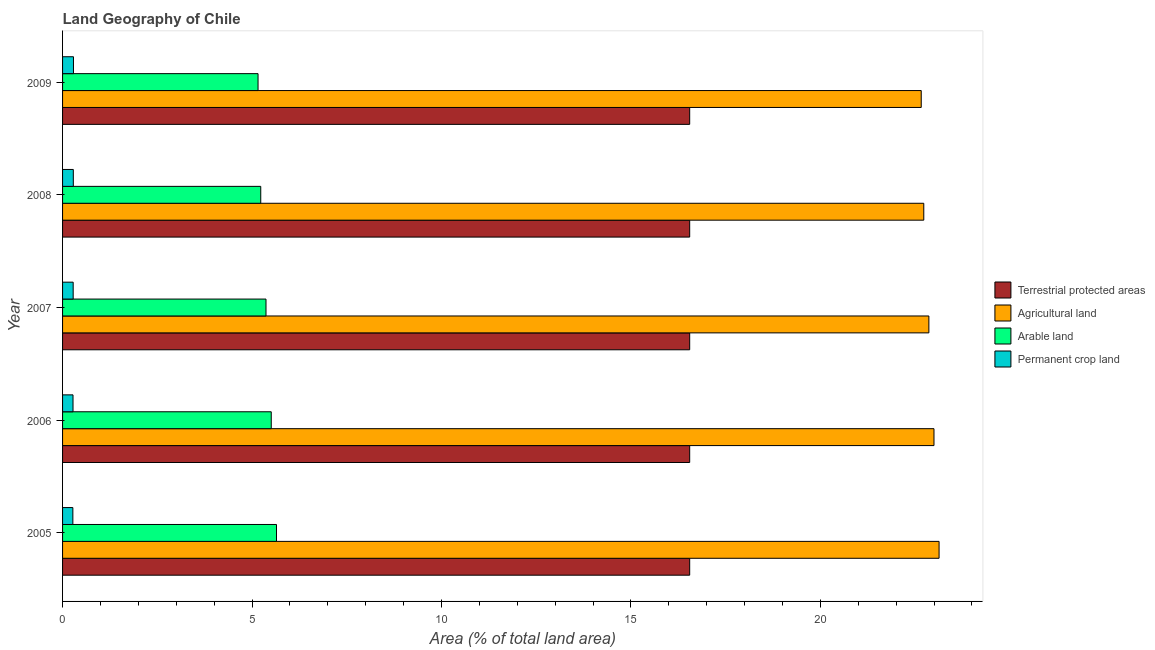Are the number of bars on each tick of the Y-axis equal?
Keep it short and to the point. Yes. How many bars are there on the 3rd tick from the bottom?
Give a very brief answer. 4. What is the label of the 5th group of bars from the top?
Ensure brevity in your answer.  2005. What is the percentage of area under arable land in 2005?
Your answer should be compact. 5.65. Across all years, what is the maximum percentage of area under agricultural land?
Your answer should be very brief. 23.13. Across all years, what is the minimum percentage of land under terrestrial protection?
Make the answer very short. 16.55. In which year was the percentage of area under permanent crop land maximum?
Give a very brief answer. 2009. In which year was the percentage of area under permanent crop land minimum?
Provide a succinct answer. 2005. What is the total percentage of area under arable land in the graph?
Provide a succinct answer. 26.91. What is the difference between the percentage of area under agricultural land in 2005 and that in 2007?
Provide a succinct answer. 0.27. What is the difference between the percentage of land under terrestrial protection in 2006 and the percentage of area under agricultural land in 2007?
Provide a succinct answer. -6.31. What is the average percentage of area under arable land per year?
Provide a succinct answer. 5.38. In the year 2005, what is the difference between the percentage of land under terrestrial protection and percentage of area under permanent crop land?
Ensure brevity in your answer.  16.28. In how many years, is the percentage of land under terrestrial protection greater than 1 %?
Your response must be concise. 5. What is the ratio of the percentage of area under permanent crop land in 2006 to that in 2009?
Ensure brevity in your answer.  0.96. What is the difference between the highest and the second highest percentage of area under permanent crop land?
Ensure brevity in your answer.  0. What is the difference between the highest and the lowest percentage of land under terrestrial protection?
Ensure brevity in your answer.  0. In how many years, is the percentage of land under terrestrial protection greater than the average percentage of land under terrestrial protection taken over all years?
Give a very brief answer. 0. Is the sum of the percentage of land under terrestrial protection in 2008 and 2009 greater than the maximum percentage of area under permanent crop land across all years?
Your answer should be compact. Yes. Is it the case that in every year, the sum of the percentage of area under agricultural land and percentage of area under permanent crop land is greater than the sum of percentage of land under terrestrial protection and percentage of area under arable land?
Give a very brief answer. Yes. What does the 2nd bar from the top in 2007 represents?
Ensure brevity in your answer.  Arable land. What does the 3rd bar from the bottom in 2006 represents?
Make the answer very short. Arable land. Is it the case that in every year, the sum of the percentage of land under terrestrial protection and percentage of area under agricultural land is greater than the percentage of area under arable land?
Offer a terse response. Yes. How many bars are there?
Your response must be concise. 20. How many years are there in the graph?
Provide a succinct answer. 5. Does the graph contain any zero values?
Ensure brevity in your answer.  No. How are the legend labels stacked?
Make the answer very short. Vertical. What is the title of the graph?
Give a very brief answer. Land Geography of Chile. Does "Rule based governance" appear as one of the legend labels in the graph?
Provide a short and direct response. No. What is the label or title of the X-axis?
Offer a very short reply. Area (% of total land area). What is the Area (% of total land area) of Terrestrial protected areas in 2005?
Keep it short and to the point. 16.55. What is the Area (% of total land area) of Agricultural land in 2005?
Make the answer very short. 23.13. What is the Area (% of total land area) in Arable land in 2005?
Ensure brevity in your answer.  5.65. What is the Area (% of total land area) in Permanent crop land in 2005?
Provide a succinct answer. 0.27. What is the Area (% of total land area) in Terrestrial protected areas in 2006?
Offer a very short reply. 16.55. What is the Area (% of total land area) in Agricultural land in 2006?
Ensure brevity in your answer.  23. What is the Area (% of total land area) of Arable land in 2006?
Your answer should be compact. 5.51. What is the Area (% of total land area) of Permanent crop land in 2006?
Keep it short and to the point. 0.28. What is the Area (% of total land area) in Terrestrial protected areas in 2007?
Ensure brevity in your answer.  16.55. What is the Area (% of total land area) in Agricultural land in 2007?
Ensure brevity in your answer.  22.86. What is the Area (% of total land area) in Arable land in 2007?
Ensure brevity in your answer.  5.37. What is the Area (% of total land area) in Permanent crop land in 2007?
Ensure brevity in your answer.  0.28. What is the Area (% of total land area) of Terrestrial protected areas in 2008?
Your answer should be compact. 16.55. What is the Area (% of total land area) in Agricultural land in 2008?
Ensure brevity in your answer.  22.73. What is the Area (% of total land area) in Arable land in 2008?
Ensure brevity in your answer.  5.23. What is the Area (% of total land area) in Permanent crop land in 2008?
Ensure brevity in your answer.  0.28. What is the Area (% of total land area) of Terrestrial protected areas in 2009?
Provide a short and direct response. 16.55. What is the Area (% of total land area) of Agricultural land in 2009?
Your response must be concise. 22.66. What is the Area (% of total land area) in Arable land in 2009?
Ensure brevity in your answer.  5.16. What is the Area (% of total land area) of Permanent crop land in 2009?
Make the answer very short. 0.29. Across all years, what is the maximum Area (% of total land area) of Terrestrial protected areas?
Give a very brief answer. 16.55. Across all years, what is the maximum Area (% of total land area) in Agricultural land?
Give a very brief answer. 23.13. Across all years, what is the maximum Area (% of total land area) in Arable land?
Give a very brief answer. 5.65. Across all years, what is the maximum Area (% of total land area) in Permanent crop land?
Give a very brief answer. 0.29. Across all years, what is the minimum Area (% of total land area) of Terrestrial protected areas?
Provide a succinct answer. 16.55. Across all years, what is the minimum Area (% of total land area) in Agricultural land?
Your answer should be very brief. 22.66. Across all years, what is the minimum Area (% of total land area) of Arable land?
Ensure brevity in your answer.  5.16. Across all years, what is the minimum Area (% of total land area) of Permanent crop land?
Give a very brief answer. 0.27. What is the total Area (% of total land area) in Terrestrial protected areas in the graph?
Offer a very short reply. 82.75. What is the total Area (% of total land area) of Agricultural land in the graph?
Provide a short and direct response. 114.39. What is the total Area (% of total land area) in Arable land in the graph?
Your answer should be compact. 26.91. What is the total Area (% of total land area) in Permanent crop land in the graph?
Your answer should be very brief. 1.4. What is the difference between the Area (% of total land area) of Agricultural land in 2005 and that in 2006?
Your answer should be compact. 0.13. What is the difference between the Area (% of total land area) in Arable land in 2005 and that in 2006?
Give a very brief answer. 0.14. What is the difference between the Area (% of total land area) in Permanent crop land in 2005 and that in 2006?
Your response must be concise. -0. What is the difference between the Area (% of total land area) of Terrestrial protected areas in 2005 and that in 2007?
Your answer should be very brief. 0. What is the difference between the Area (% of total land area) in Agricultural land in 2005 and that in 2007?
Your answer should be very brief. 0.27. What is the difference between the Area (% of total land area) of Arable land in 2005 and that in 2007?
Provide a succinct answer. 0.28. What is the difference between the Area (% of total land area) of Permanent crop land in 2005 and that in 2007?
Keep it short and to the point. -0.01. What is the difference between the Area (% of total land area) of Terrestrial protected areas in 2005 and that in 2008?
Your answer should be very brief. 0. What is the difference between the Area (% of total land area) in Agricultural land in 2005 and that in 2008?
Provide a succinct answer. 0.4. What is the difference between the Area (% of total land area) of Arable land in 2005 and that in 2008?
Your answer should be very brief. 0.42. What is the difference between the Area (% of total land area) in Permanent crop land in 2005 and that in 2008?
Provide a succinct answer. -0.01. What is the difference between the Area (% of total land area) of Agricultural land in 2005 and that in 2009?
Provide a succinct answer. 0.47. What is the difference between the Area (% of total land area) of Arable land in 2005 and that in 2009?
Your answer should be compact. 0.49. What is the difference between the Area (% of total land area) in Permanent crop land in 2005 and that in 2009?
Provide a short and direct response. -0.02. What is the difference between the Area (% of total land area) of Terrestrial protected areas in 2006 and that in 2007?
Give a very brief answer. 0. What is the difference between the Area (% of total land area) in Agricultural land in 2006 and that in 2007?
Keep it short and to the point. 0.13. What is the difference between the Area (% of total land area) of Arable land in 2006 and that in 2007?
Offer a very short reply. 0.14. What is the difference between the Area (% of total land area) of Permanent crop land in 2006 and that in 2007?
Your answer should be very brief. -0. What is the difference between the Area (% of total land area) in Terrestrial protected areas in 2006 and that in 2008?
Offer a very short reply. 0. What is the difference between the Area (% of total land area) of Agricultural land in 2006 and that in 2008?
Offer a terse response. 0.27. What is the difference between the Area (% of total land area) of Arable land in 2006 and that in 2008?
Offer a very short reply. 0.28. What is the difference between the Area (% of total land area) of Permanent crop land in 2006 and that in 2008?
Your response must be concise. -0.01. What is the difference between the Area (% of total land area) of Agricultural land in 2006 and that in 2009?
Your answer should be compact. 0.34. What is the difference between the Area (% of total land area) in Arable land in 2006 and that in 2009?
Offer a very short reply. 0.35. What is the difference between the Area (% of total land area) in Permanent crop land in 2006 and that in 2009?
Your response must be concise. -0.01. What is the difference between the Area (% of total land area) in Terrestrial protected areas in 2007 and that in 2008?
Your answer should be compact. 0. What is the difference between the Area (% of total land area) of Agricultural land in 2007 and that in 2008?
Provide a succinct answer. 0.13. What is the difference between the Area (% of total land area) in Arable land in 2007 and that in 2008?
Your answer should be compact. 0.14. What is the difference between the Area (% of total land area) of Permanent crop land in 2007 and that in 2008?
Your answer should be compact. -0. What is the difference between the Area (% of total land area) in Terrestrial protected areas in 2007 and that in 2009?
Make the answer very short. 0. What is the difference between the Area (% of total land area) of Agricultural land in 2007 and that in 2009?
Provide a succinct answer. 0.2. What is the difference between the Area (% of total land area) in Arable land in 2007 and that in 2009?
Provide a succinct answer. 0.21. What is the difference between the Area (% of total land area) of Permanent crop land in 2007 and that in 2009?
Make the answer very short. -0.01. What is the difference between the Area (% of total land area) in Terrestrial protected areas in 2008 and that in 2009?
Your answer should be very brief. 0. What is the difference between the Area (% of total land area) of Agricultural land in 2008 and that in 2009?
Your answer should be compact. 0.07. What is the difference between the Area (% of total land area) of Arable land in 2008 and that in 2009?
Provide a succinct answer. 0.07. What is the difference between the Area (% of total land area) of Permanent crop land in 2008 and that in 2009?
Your response must be concise. -0. What is the difference between the Area (% of total land area) of Terrestrial protected areas in 2005 and the Area (% of total land area) of Agricultural land in 2006?
Keep it short and to the point. -6.45. What is the difference between the Area (% of total land area) of Terrestrial protected areas in 2005 and the Area (% of total land area) of Arable land in 2006?
Provide a succinct answer. 11.04. What is the difference between the Area (% of total land area) in Terrestrial protected areas in 2005 and the Area (% of total land area) in Permanent crop land in 2006?
Your answer should be compact. 16.28. What is the difference between the Area (% of total land area) in Agricultural land in 2005 and the Area (% of total land area) in Arable land in 2006?
Give a very brief answer. 17.63. What is the difference between the Area (% of total land area) of Agricultural land in 2005 and the Area (% of total land area) of Permanent crop land in 2006?
Provide a succinct answer. 22.86. What is the difference between the Area (% of total land area) in Arable land in 2005 and the Area (% of total land area) in Permanent crop land in 2006?
Make the answer very short. 5.37. What is the difference between the Area (% of total land area) in Terrestrial protected areas in 2005 and the Area (% of total land area) in Agricultural land in 2007?
Offer a terse response. -6.31. What is the difference between the Area (% of total land area) in Terrestrial protected areas in 2005 and the Area (% of total land area) in Arable land in 2007?
Ensure brevity in your answer.  11.18. What is the difference between the Area (% of total land area) in Terrestrial protected areas in 2005 and the Area (% of total land area) in Permanent crop land in 2007?
Provide a short and direct response. 16.27. What is the difference between the Area (% of total land area) of Agricultural land in 2005 and the Area (% of total land area) of Arable land in 2007?
Make the answer very short. 17.76. What is the difference between the Area (% of total land area) in Agricultural land in 2005 and the Area (% of total land area) in Permanent crop land in 2007?
Make the answer very short. 22.85. What is the difference between the Area (% of total land area) in Arable land in 2005 and the Area (% of total land area) in Permanent crop land in 2007?
Your response must be concise. 5.37. What is the difference between the Area (% of total land area) in Terrestrial protected areas in 2005 and the Area (% of total land area) in Agricultural land in 2008?
Your answer should be very brief. -6.18. What is the difference between the Area (% of total land area) in Terrestrial protected areas in 2005 and the Area (% of total land area) in Arable land in 2008?
Keep it short and to the point. 11.32. What is the difference between the Area (% of total land area) of Terrestrial protected areas in 2005 and the Area (% of total land area) of Permanent crop land in 2008?
Your response must be concise. 16.27. What is the difference between the Area (% of total land area) of Agricultural land in 2005 and the Area (% of total land area) of Arable land in 2008?
Keep it short and to the point. 17.9. What is the difference between the Area (% of total land area) in Agricultural land in 2005 and the Area (% of total land area) in Permanent crop land in 2008?
Your answer should be very brief. 22.85. What is the difference between the Area (% of total land area) in Arable land in 2005 and the Area (% of total land area) in Permanent crop land in 2008?
Offer a very short reply. 5.36. What is the difference between the Area (% of total land area) in Terrestrial protected areas in 2005 and the Area (% of total land area) in Agricultural land in 2009?
Your response must be concise. -6.11. What is the difference between the Area (% of total land area) in Terrestrial protected areas in 2005 and the Area (% of total land area) in Arable land in 2009?
Make the answer very short. 11.39. What is the difference between the Area (% of total land area) in Terrestrial protected areas in 2005 and the Area (% of total land area) in Permanent crop land in 2009?
Provide a short and direct response. 16.26. What is the difference between the Area (% of total land area) in Agricultural land in 2005 and the Area (% of total land area) in Arable land in 2009?
Offer a terse response. 17.97. What is the difference between the Area (% of total land area) of Agricultural land in 2005 and the Area (% of total land area) of Permanent crop land in 2009?
Keep it short and to the point. 22.84. What is the difference between the Area (% of total land area) of Arable land in 2005 and the Area (% of total land area) of Permanent crop land in 2009?
Provide a succinct answer. 5.36. What is the difference between the Area (% of total land area) of Terrestrial protected areas in 2006 and the Area (% of total land area) of Agricultural land in 2007?
Your answer should be very brief. -6.31. What is the difference between the Area (% of total land area) in Terrestrial protected areas in 2006 and the Area (% of total land area) in Arable land in 2007?
Provide a short and direct response. 11.18. What is the difference between the Area (% of total land area) of Terrestrial protected areas in 2006 and the Area (% of total land area) of Permanent crop land in 2007?
Ensure brevity in your answer.  16.27. What is the difference between the Area (% of total land area) of Agricultural land in 2006 and the Area (% of total land area) of Arable land in 2007?
Keep it short and to the point. 17.63. What is the difference between the Area (% of total land area) in Agricultural land in 2006 and the Area (% of total land area) in Permanent crop land in 2007?
Ensure brevity in your answer.  22.72. What is the difference between the Area (% of total land area) of Arable land in 2006 and the Area (% of total land area) of Permanent crop land in 2007?
Your answer should be compact. 5.23. What is the difference between the Area (% of total land area) in Terrestrial protected areas in 2006 and the Area (% of total land area) in Agricultural land in 2008?
Your answer should be very brief. -6.18. What is the difference between the Area (% of total land area) of Terrestrial protected areas in 2006 and the Area (% of total land area) of Arable land in 2008?
Give a very brief answer. 11.32. What is the difference between the Area (% of total land area) of Terrestrial protected areas in 2006 and the Area (% of total land area) of Permanent crop land in 2008?
Provide a short and direct response. 16.27. What is the difference between the Area (% of total land area) of Agricultural land in 2006 and the Area (% of total land area) of Arable land in 2008?
Your answer should be very brief. 17.77. What is the difference between the Area (% of total land area) in Agricultural land in 2006 and the Area (% of total land area) in Permanent crop land in 2008?
Ensure brevity in your answer.  22.71. What is the difference between the Area (% of total land area) of Arable land in 2006 and the Area (% of total land area) of Permanent crop land in 2008?
Offer a very short reply. 5.22. What is the difference between the Area (% of total land area) of Terrestrial protected areas in 2006 and the Area (% of total land area) of Agricultural land in 2009?
Make the answer very short. -6.11. What is the difference between the Area (% of total land area) in Terrestrial protected areas in 2006 and the Area (% of total land area) in Arable land in 2009?
Provide a succinct answer. 11.39. What is the difference between the Area (% of total land area) in Terrestrial protected areas in 2006 and the Area (% of total land area) in Permanent crop land in 2009?
Offer a very short reply. 16.26. What is the difference between the Area (% of total land area) in Agricultural land in 2006 and the Area (% of total land area) in Arable land in 2009?
Your response must be concise. 17.84. What is the difference between the Area (% of total land area) in Agricultural land in 2006 and the Area (% of total land area) in Permanent crop land in 2009?
Offer a terse response. 22.71. What is the difference between the Area (% of total land area) of Arable land in 2006 and the Area (% of total land area) of Permanent crop land in 2009?
Provide a short and direct response. 5.22. What is the difference between the Area (% of total land area) of Terrestrial protected areas in 2007 and the Area (% of total land area) of Agricultural land in 2008?
Give a very brief answer. -6.18. What is the difference between the Area (% of total land area) in Terrestrial protected areas in 2007 and the Area (% of total land area) in Arable land in 2008?
Your response must be concise. 11.32. What is the difference between the Area (% of total land area) in Terrestrial protected areas in 2007 and the Area (% of total land area) in Permanent crop land in 2008?
Offer a very short reply. 16.27. What is the difference between the Area (% of total land area) in Agricultural land in 2007 and the Area (% of total land area) in Arable land in 2008?
Your answer should be compact. 17.63. What is the difference between the Area (% of total land area) in Agricultural land in 2007 and the Area (% of total land area) in Permanent crop land in 2008?
Offer a terse response. 22.58. What is the difference between the Area (% of total land area) in Arable land in 2007 and the Area (% of total land area) in Permanent crop land in 2008?
Offer a terse response. 5.09. What is the difference between the Area (% of total land area) of Terrestrial protected areas in 2007 and the Area (% of total land area) of Agricultural land in 2009?
Provide a succinct answer. -6.11. What is the difference between the Area (% of total land area) of Terrestrial protected areas in 2007 and the Area (% of total land area) of Arable land in 2009?
Your response must be concise. 11.39. What is the difference between the Area (% of total land area) of Terrestrial protected areas in 2007 and the Area (% of total land area) of Permanent crop land in 2009?
Make the answer very short. 16.26. What is the difference between the Area (% of total land area) in Agricultural land in 2007 and the Area (% of total land area) in Arable land in 2009?
Make the answer very short. 17.7. What is the difference between the Area (% of total land area) of Agricultural land in 2007 and the Area (% of total land area) of Permanent crop land in 2009?
Your answer should be compact. 22.58. What is the difference between the Area (% of total land area) in Arable land in 2007 and the Area (% of total land area) in Permanent crop land in 2009?
Provide a succinct answer. 5.08. What is the difference between the Area (% of total land area) in Terrestrial protected areas in 2008 and the Area (% of total land area) in Agricultural land in 2009?
Provide a succinct answer. -6.11. What is the difference between the Area (% of total land area) in Terrestrial protected areas in 2008 and the Area (% of total land area) in Arable land in 2009?
Provide a short and direct response. 11.39. What is the difference between the Area (% of total land area) in Terrestrial protected areas in 2008 and the Area (% of total land area) in Permanent crop land in 2009?
Provide a short and direct response. 16.26. What is the difference between the Area (% of total land area) of Agricultural land in 2008 and the Area (% of total land area) of Arable land in 2009?
Offer a very short reply. 17.57. What is the difference between the Area (% of total land area) of Agricultural land in 2008 and the Area (% of total land area) of Permanent crop land in 2009?
Your answer should be compact. 22.44. What is the difference between the Area (% of total land area) of Arable land in 2008 and the Area (% of total land area) of Permanent crop land in 2009?
Make the answer very short. 4.94. What is the average Area (% of total land area) in Terrestrial protected areas per year?
Your response must be concise. 16.55. What is the average Area (% of total land area) in Agricultural land per year?
Offer a very short reply. 22.88. What is the average Area (% of total land area) in Arable land per year?
Your answer should be compact. 5.38. What is the average Area (% of total land area) in Permanent crop land per year?
Provide a succinct answer. 0.28. In the year 2005, what is the difference between the Area (% of total land area) of Terrestrial protected areas and Area (% of total land area) of Agricultural land?
Your answer should be compact. -6.58. In the year 2005, what is the difference between the Area (% of total land area) of Terrestrial protected areas and Area (% of total land area) of Arable land?
Ensure brevity in your answer.  10.9. In the year 2005, what is the difference between the Area (% of total land area) of Terrestrial protected areas and Area (% of total land area) of Permanent crop land?
Provide a short and direct response. 16.28. In the year 2005, what is the difference between the Area (% of total land area) of Agricultural land and Area (% of total land area) of Arable land?
Ensure brevity in your answer.  17.49. In the year 2005, what is the difference between the Area (% of total land area) in Agricultural land and Area (% of total land area) in Permanent crop land?
Make the answer very short. 22.86. In the year 2005, what is the difference between the Area (% of total land area) in Arable land and Area (% of total land area) in Permanent crop land?
Your answer should be very brief. 5.37. In the year 2006, what is the difference between the Area (% of total land area) in Terrestrial protected areas and Area (% of total land area) in Agricultural land?
Keep it short and to the point. -6.45. In the year 2006, what is the difference between the Area (% of total land area) of Terrestrial protected areas and Area (% of total land area) of Arable land?
Offer a terse response. 11.04. In the year 2006, what is the difference between the Area (% of total land area) of Terrestrial protected areas and Area (% of total land area) of Permanent crop land?
Ensure brevity in your answer.  16.28. In the year 2006, what is the difference between the Area (% of total land area) of Agricultural land and Area (% of total land area) of Arable land?
Your response must be concise. 17.49. In the year 2006, what is the difference between the Area (% of total land area) of Agricultural land and Area (% of total land area) of Permanent crop land?
Make the answer very short. 22.72. In the year 2006, what is the difference between the Area (% of total land area) in Arable land and Area (% of total land area) in Permanent crop land?
Offer a terse response. 5.23. In the year 2007, what is the difference between the Area (% of total land area) of Terrestrial protected areas and Area (% of total land area) of Agricultural land?
Give a very brief answer. -6.31. In the year 2007, what is the difference between the Area (% of total land area) of Terrestrial protected areas and Area (% of total land area) of Arable land?
Your answer should be compact. 11.18. In the year 2007, what is the difference between the Area (% of total land area) of Terrestrial protected areas and Area (% of total land area) of Permanent crop land?
Offer a terse response. 16.27. In the year 2007, what is the difference between the Area (% of total land area) in Agricultural land and Area (% of total land area) in Arable land?
Offer a very short reply. 17.49. In the year 2007, what is the difference between the Area (% of total land area) of Agricultural land and Area (% of total land area) of Permanent crop land?
Provide a short and direct response. 22.58. In the year 2007, what is the difference between the Area (% of total land area) of Arable land and Area (% of total land area) of Permanent crop land?
Make the answer very short. 5.09. In the year 2008, what is the difference between the Area (% of total land area) in Terrestrial protected areas and Area (% of total land area) in Agricultural land?
Offer a very short reply. -6.18. In the year 2008, what is the difference between the Area (% of total land area) in Terrestrial protected areas and Area (% of total land area) in Arable land?
Offer a very short reply. 11.32. In the year 2008, what is the difference between the Area (% of total land area) in Terrestrial protected areas and Area (% of total land area) in Permanent crop land?
Your response must be concise. 16.27. In the year 2008, what is the difference between the Area (% of total land area) of Agricultural land and Area (% of total land area) of Arable land?
Provide a short and direct response. 17.5. In the year 2008, what is the difference between the Area (% of total land area) in Agricultural land and Area (% of total land area) in Permanent crop land?
Provide a succinct answer. 22.45. In the year 2008, what is the difference between the Area (% of total land area) of Arable land and Area (% of total land area) of Permanent crop land?
Your answer should be very brief. 4.95. In the year 2009, what is the difference between the Area (% of total land area) in Terrestrial protected areas and Area (% of total land area) in Agricultural land?
Give a very brief answer. -6.11. In the year 2009, what is the difference between the Area (% of total land area) of Terrestrial protected areas and Area (% of total land area) of Arable land?
Offer a terse response. 11.39. In the year 2009, what is the difference between the Area (% of total land area) of Terrestrial protected areas and Area (% of total land area) of Permanent crop land?
Provide a succinct answer. 16.26. In the year 2009, what is the difference between the Area (% of total land area) of Agricultural land and Area (% of total land area) of Arable land?
Offer a terse response. 17.5. In the year 2009, what is the difference between the Area (% of total land area) in Agricultural land and Area (% of total land area) in Permanent crop land?
Ensure brevity in your answer.  22.37. In the year 2009, what is the difference between the Area (% of total land area) of Arable land and Area (% of total land area) of Permanent crop land?
Offer a terse response. 4.87. What is the ratio of the Area (% of total land area) of Terrestrial protected areas in 2005 to that in 2006?
Offer a terse response. 1. What is the ratio of the Area (% of total land area) in Arable land in 2005 to that in 2006?
Provide a short and direct response. 1.03. What is the ratio of the Area (% of total land area) in Permanent crop land in 2005 to that in 2006?
Make the answer very short. 0.99. What is the ratio of the Area (% of total land area) of Agricultural land in 2005 to that in 2007?
Provide a short and direct response. 1.01. What is the ratio of the Area (% of total land area) of Arable land in 2005 to that in 2007?
Give a very brief answer. 1.05. What is the ratio of the Area (% of total land area) of Permanent crop land in 2005 to that in 2007?
Keep it short and to the point. 0.97. What is the ratio of the Area (% of total land area) in Agricultural land in 2005 to that in 2008?
Make the answer very short. 1.02. What is the ratio of the Area (% of total land area) in Arable land in 2005 to that in 2008?
Ensure brevity in your answer.  1.08. What is the ratio of the Area (% of total land area) of Permanent crop land in 2005 to that in 2008?
Give a very brief answer. 0.96. What is the ratio of the Area (% of total land area) of Terrestrial protected areas in 2005 to that in 2009?
Provide a succinct answer. 1. What is the ratio of the Area (% of total land area) of Agricultural land in 2005 to that in 2009?
Your answer should be very brief. 1.02. What is the ratio of the Area (% of total land area) of Arable land in 2005 to that in 2009?
Keep it short and to the point. 1.09. What is the ratio of the Area (% of total land area) in Permanent crop land in 2005 to that in 2009?
Keep it short and to the point. 0.94. What is the ratio of the Area (% of total land area) of Terrestrial protected areas in 2006 to that in 2007?
Offer a very short reply. 1. What is the ratio of the Area (% of total land area) of Agricultural land in 2006 to that in 2007?
Your answer should be compact. 1.01. What is the ratio of the Area (% of total land area) of Arable land in 2006 to that in 2007?
Your answer should be very brief. 1.03. What is the ratio of the Area (% of total land area) in Permanent crop land in 2006 to that in 2007?
Ensure brevity in your answer.  0.99. What is the ratio of the Area (% of total land area) of Terrestrial protected areas in 2006 to that in 2008?
Provide a short and direct response. 1. What is the ratio of the Area (% of total land area) in Agricultural land in 2006 to that in 2008?
Offer a very short reply. 1.01. What is the ratio of the Area (% of total land area) of Arable land in 2006 to that in 2008?
Offer a terse response. 1.05. What is the ratio of the Area (% of total land area) in Permanent crop land in 2006 to that in 2008?
Provide a succinct answer. 0.97. What is the ratio of the Area (% of total land area) of Agricultural land in 2006 to that in 2009?
Your response must be concise. 1.01. What is the ratio of the Area (% of total land area) in Arable land in 2006 to that in 2009?
Keep it short and to the point. 1.07. What is the ratio of the Area (% of total land area) of Permanent crop land in 2006 to that in 2009?
Provide a short and direct response. 0.96. What is the ratio of the Area (% of total land area) of Terrestrial protected areas in 2007 to that in 2008?
Provide a short and direct response. 1. What is the ratio of the Area (% of total land area) of Agricultural land in 2007 to that in 2008?
Offer a terse response. 1.01. What is the ratio of the Area (% of total land area) in Arable land in 2007 to that in 2008?
Give a very brief answer. 1.03. What is the ratio of the Area (% of total land area) of Permanent crop land in 2007 to that in 2008?
Your answer should be very brief. 0.99. What is the ratio of the Area (% of total land area) of Terrestrial protected areas in 2007 to that in 2009?
Make the answer very short. 1. What is the ratio of the Area (% of total land area) in Agricultural land in 2007 to that in 2009?
Offer a very short reply. 1.01. What is the ratio of the Area (% of total land area) of Arable land in 2007 to that in 2009?
Offer a very short reply. 1.04. What is the ratio of the Area (% of total land area) of Arable land in 2008 to that in 2009?
Your response must be concise. 1.01. What is the difference between the highest and the second highest Area (% of total land area) of Agricultural land?
Offer a terse response. 0.13. What is the difference between the highest and the second highest Area (% of total land area) of Arable land?
Make the answer very short. 0.14. What is the difference between the highest and the second highest Area (% of total land area) of Permanent crop land?
Offer a terse response. 0. What is the difference between the highest and the lowest Area (% of total land area) in Terrestrial protected areas?
Offer a very short reply. 0. What is the difference between the highest and the lowest Area (% of total land area) of Agricultural land?
Keep it short and to the point. 0.47. What is the difference between the highest and the lowest Area (% of total land area) of Arable land?
Offer a terse response. 0.49. What is the difference between the highest and the lowest Area (% of total land area) of Permanent crop land?
Give a very brief answer. 0.02. 